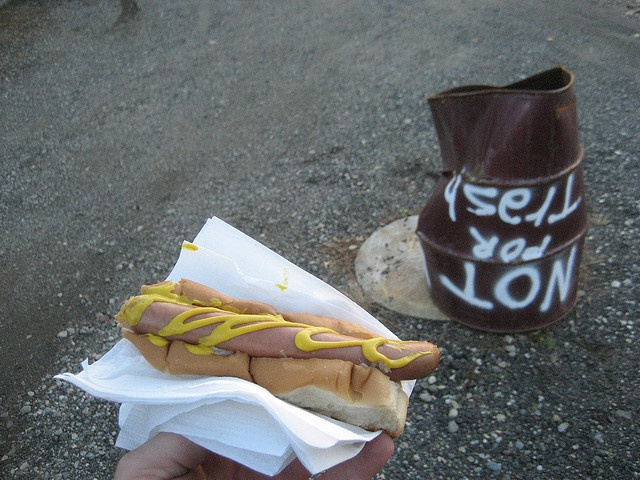Describe the objects in this image and their specific colors. I can see hot dog in purple, gray, tan, and darkgray tones and people in purple, gray, maroon, and black tones in this image. 